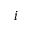<formula> <loc_0><loc_0><loc_500><loc_500>i</formula> 